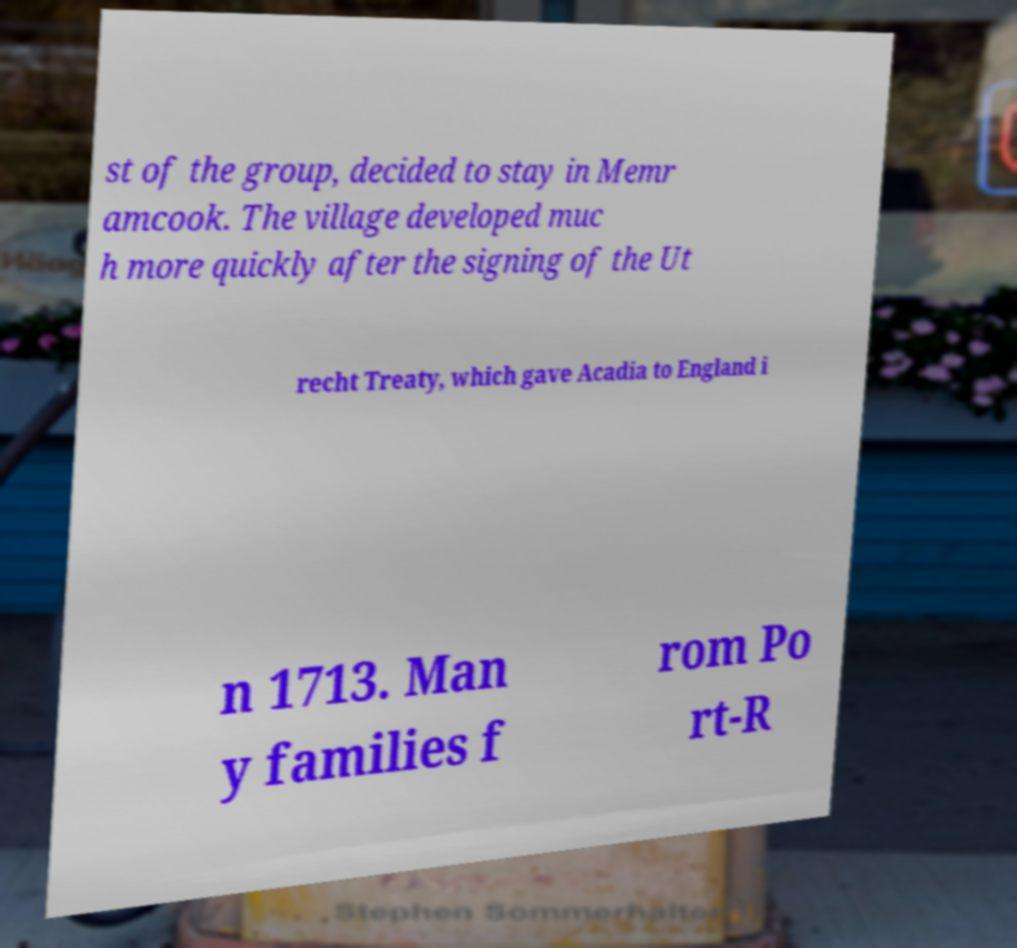Could you extract and type out the text from this image? st of the group, decided to stay in Memr amcook. The village developed muc h more quickly after the signing of the Ut recht Treaty, which gave Acadia to England i n 1713. Man y families f rom Po rt-R 